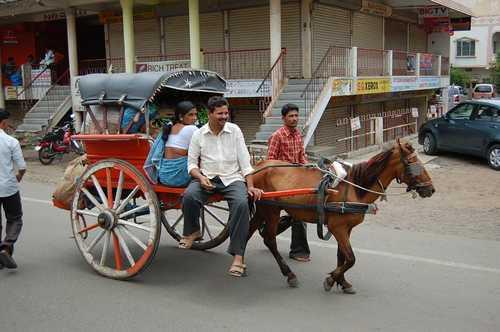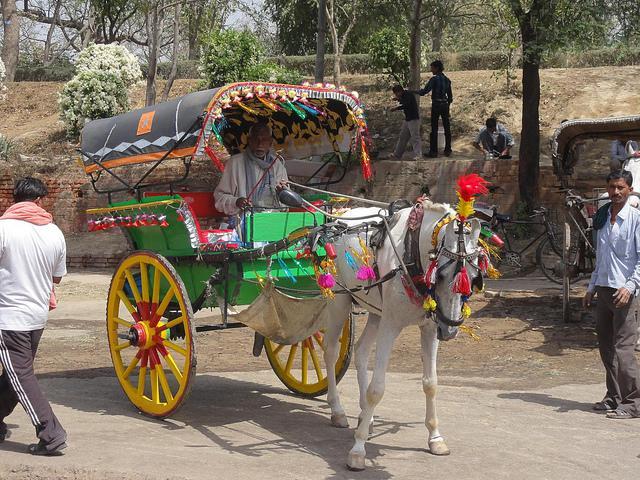The first image is the image on the left, the second image is the image on the right. Given the left and right images, does the statement "The image on the ride has a horse with a red tassel on its head." hold true? Answer yes or no. Yes. 